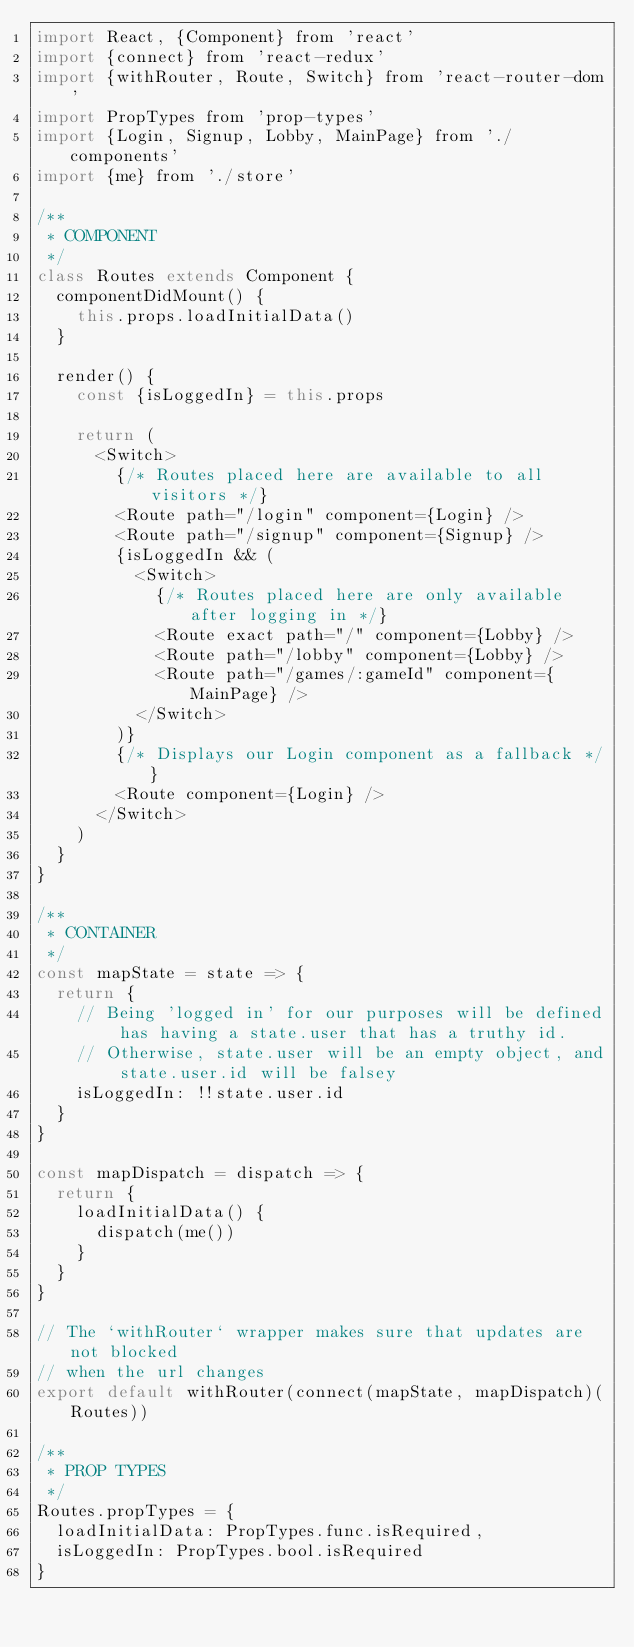<code> <loc_0><loc_0><loc_500><loc_500><_JavaScript_>import React, {Component} from 'react'
import {connect} from 'react-redux'
import {withRouter, Route, Switch} from 'react-router-dom'
import PropTypes from 'prop-types'
import {Login, Signup, Lobby, MainPage} from './components'
import {me} from './store'

/**
 * COMPONENT
 */
class Routes extends Component {
  componentDidMount() {
    this.props.loadInitialData()
  }

  render() {
    const {isLoggedIn} = this.props

    return (
      <Switch>
        {/* Routes placed here are available to all visitors */}
        <Route path="/login" component={Login} />
        <Route path="/signup" component={Signup} />
        {isLoggedIn && (
          <Switch>
            {/* Routes placed here are only available after logging in */}
            <Route exact path="/" component={Lobby} />
            <Route path="/lobby" component={Lobby} />
            <Route path="/games/:gameId" component={MainPage} />
          </Switch>
        )}
        {/* Displays our Login component as a fallback */}
        <Route component={Login} />
      </Switch>
    )
  }
}

/**
 * CONTAINER
 */
const mapState = state => {
  return {
    // Being 'logged in' for our purposes will be defined has having a state.user that has a truthy id.
    // Otherwise, state.user will be an empty object, and state.user.id will be falsey
    isLoggedIn: !!state.user.id
  }
}

const mapDispatch = dispatch => {
  return {
    loadInitialData() {
      dispatch(me())
    }
  }
}

// The `withRouter` wrapper makes sure that updates are not blocked
// when the url changes
export default withRouter(connect(mapState, mapDispatch)(Routes))

/**
 * PROP TYPES
 */
Routes.propTypes = {
  loadInitialData: PropTypes.func.isRequired,
  isLoggedIn: PropTypes.bool.isRequired
}
</code> 